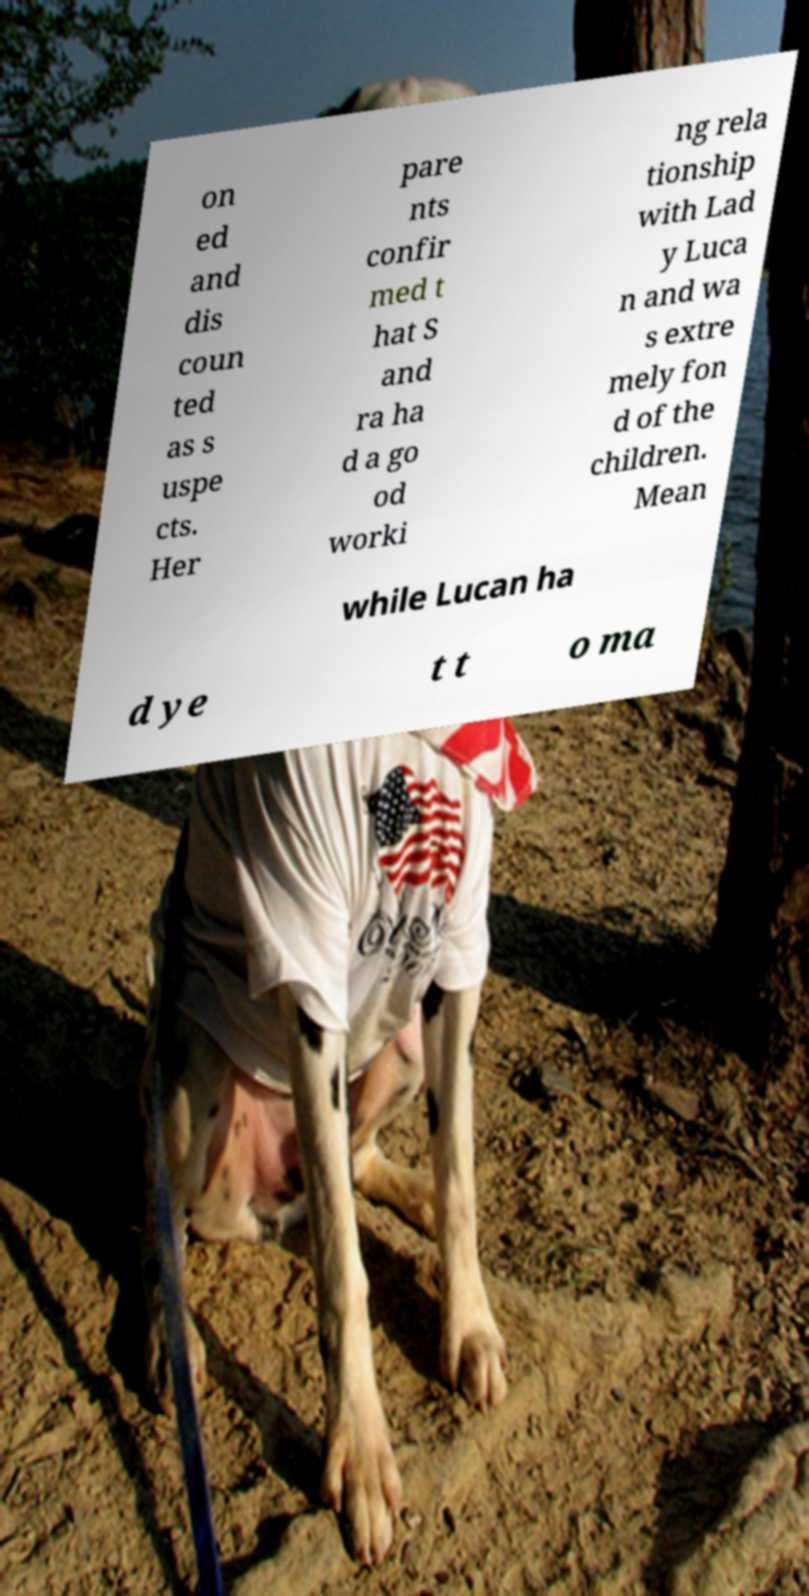Could you extract and type out the text from this image? on ed and dis coun ted as s uspe cts. Her pare nts confir med t hat S and ra ha d a go od worki ng rela tionship with Lad y Luca n and wa s extre mely fon d of the children. Mean while Lucan ha d ye t t o ma 